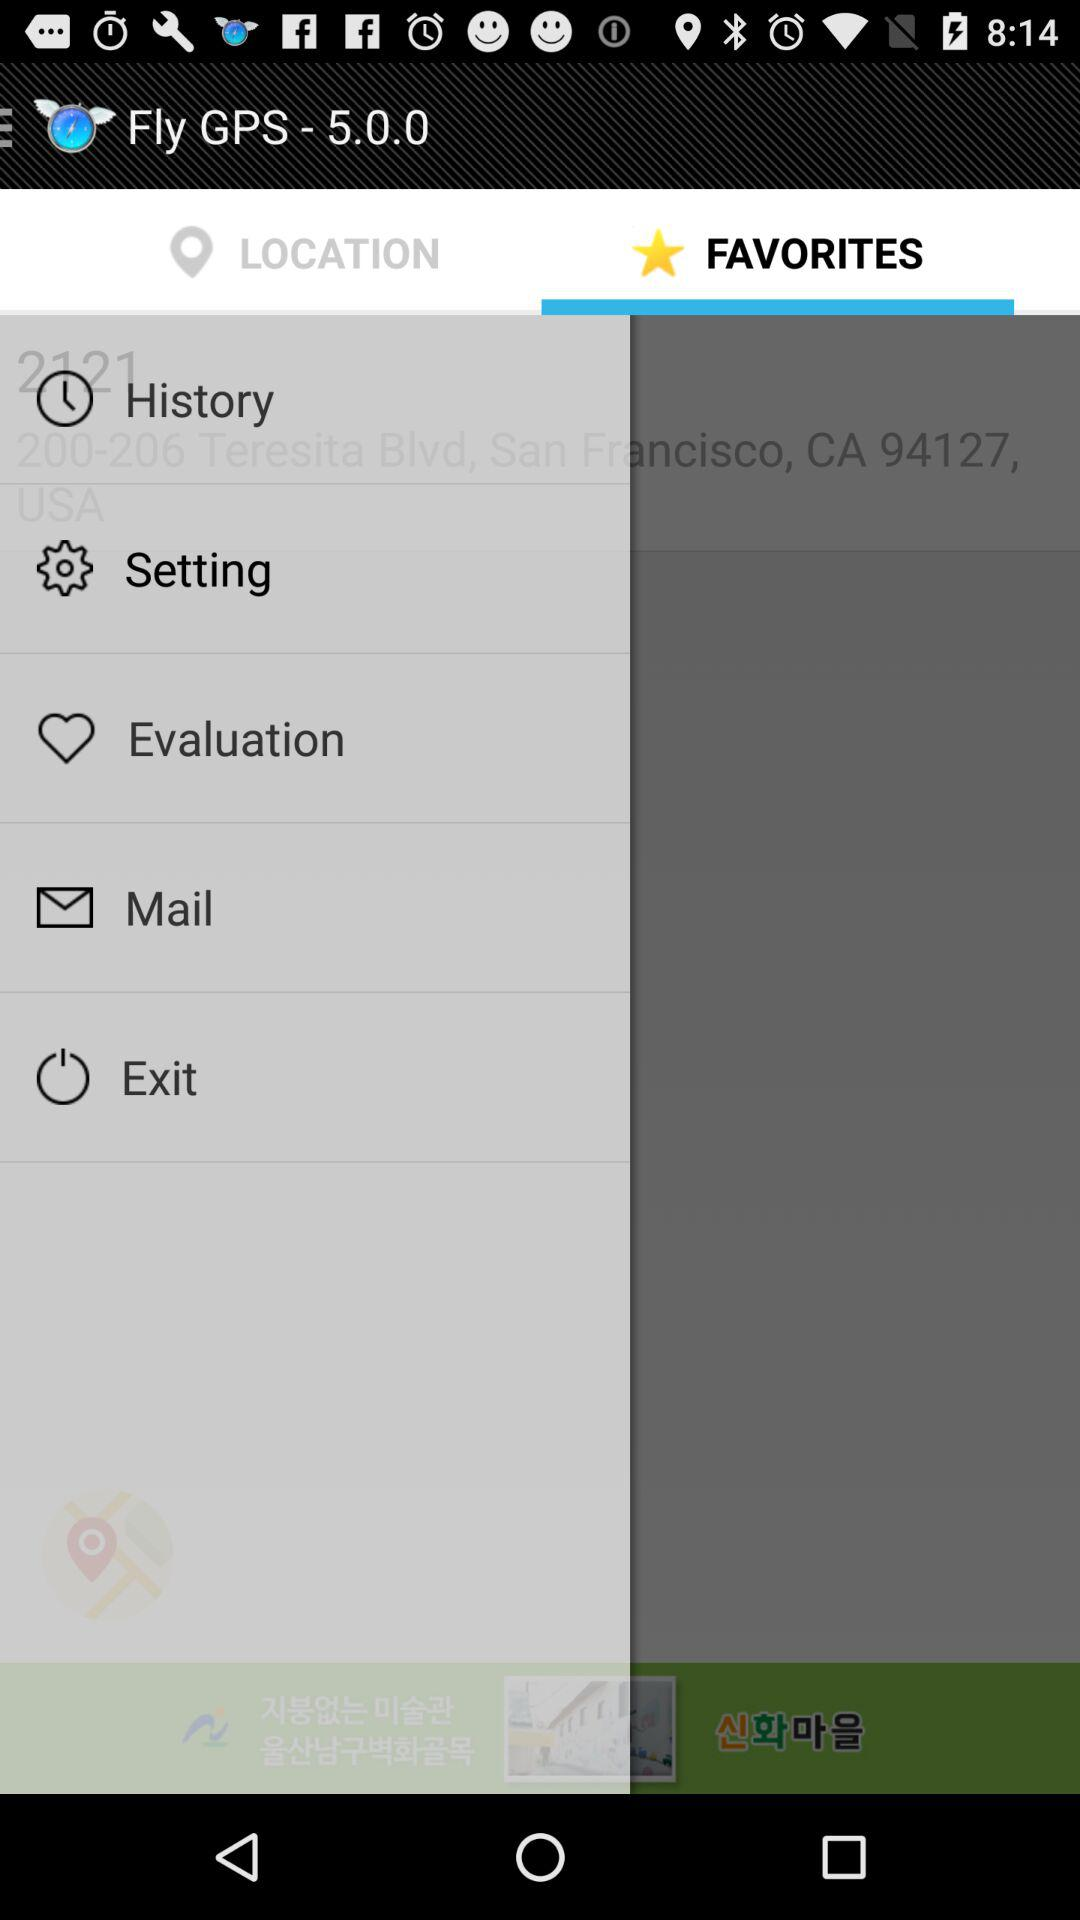What is the version of GPS? The version of GPS is 5.0.0. 